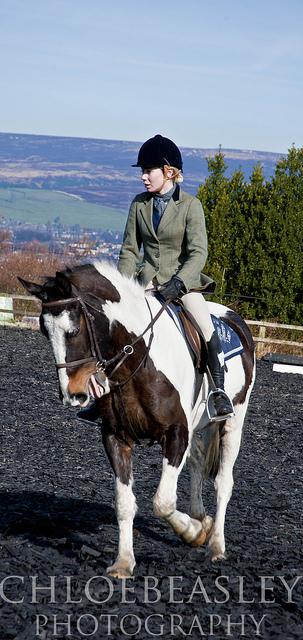Is she riding a pony?
Concise answer only. Yes. Is this Western or English style riding?
Concise answer only. English. What is the name of the photography company?
Give a very brief answer. Chloe beasley photography. 